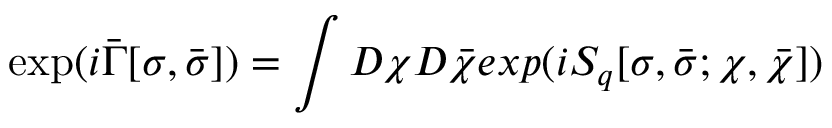Convert formula to latex. <formula><loc_0><loc_0><loc_500><loc_500>\exp ( i \bar { \Gamma } [ \sigma , \bar { \sigma } ] ) = \int D \chi D \bar { \chi } e x p ( i S _ { q } [ \sigma , \bar { \sigma } ; \chi , \bar { \chi } ] )</formula> 